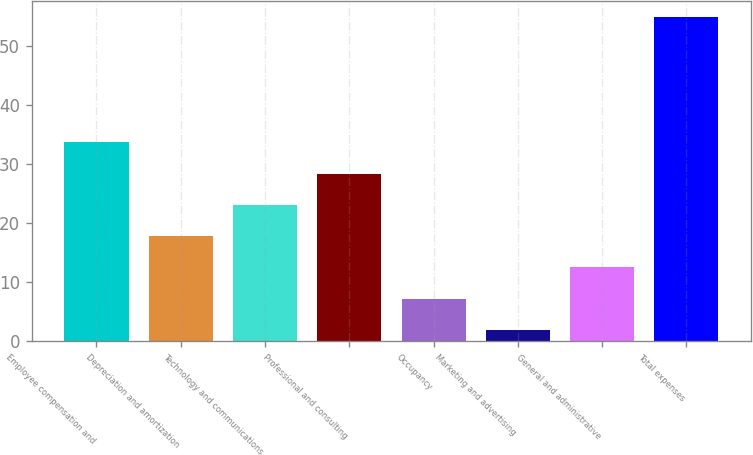<chart> <loc_0><loc_0><loc_500><loc_500><bar_chart><fcel>Employee compensation and<fcel>Depreciation and amortization<fcel>Technology and communications<fcel>Professional and consulting<fcel>Occupancy<fcel>Marketing and advertising<fcel>General and administrative<fcel>Total expenses<nl><fcel>33.76<fcel>17.83<fcel>23.14<fcel>28.45<fcel>7.21<fcel>1.9<fcel>12.52<fcel>55<nl></chart> 